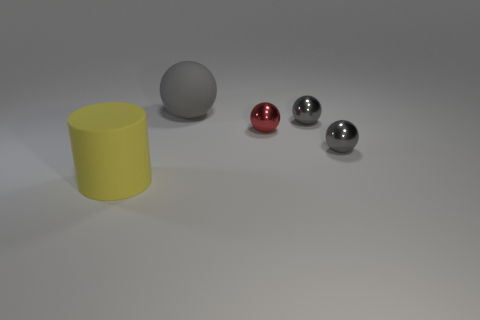How many gray balls must be subtracted to get 1 gray balls? 2 Subtract all red blocks. How many gray balls are left? 3 Subtract all gray matte balls. How many balls are left? 3 Subtract all red balls. How many balls are left? 3 Subtract all blue spheres. Subtract all green cubes. How many spheres are left? 4 Add 3 large cylinders. How many objects exist? 8 Subtract all spheres. How many objects are left? 1 Subtract all tiny blue balls. Subtract all gray spheres. How many objects are left? 2 Add 5 big matte balls. How many big matte balls are left? 6 Add 4 small gray metal objects. How many small gray metal objects exist? 6 